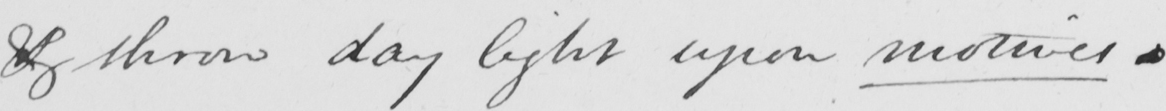Can you tell me what this handwritten text says? & throw day light upon motives . 